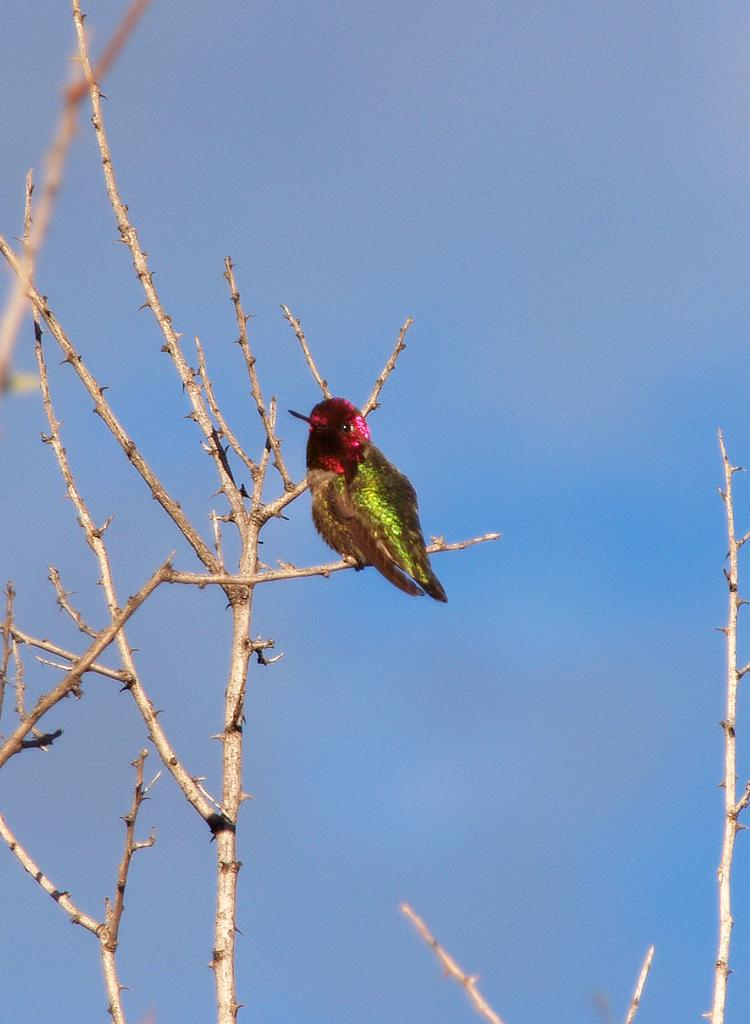What type of animal can be seen in the image? There is a bird in the image. Where is the bird located in the image? The bird is standing on the stems of a plant. What can be seen in the background of the image? There is sky visible in the background of the image. What type of destruction is the bird causing at the party in the image? There is no party or destruction present in the image; it features a bird standing on the stems of a plant with sky visible in the background. 